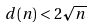Convert formula to latex. <formula><loc_0><loc_0><loc_500><loc_500>d ( n ) < 2 \sqrt { n }</formula> 